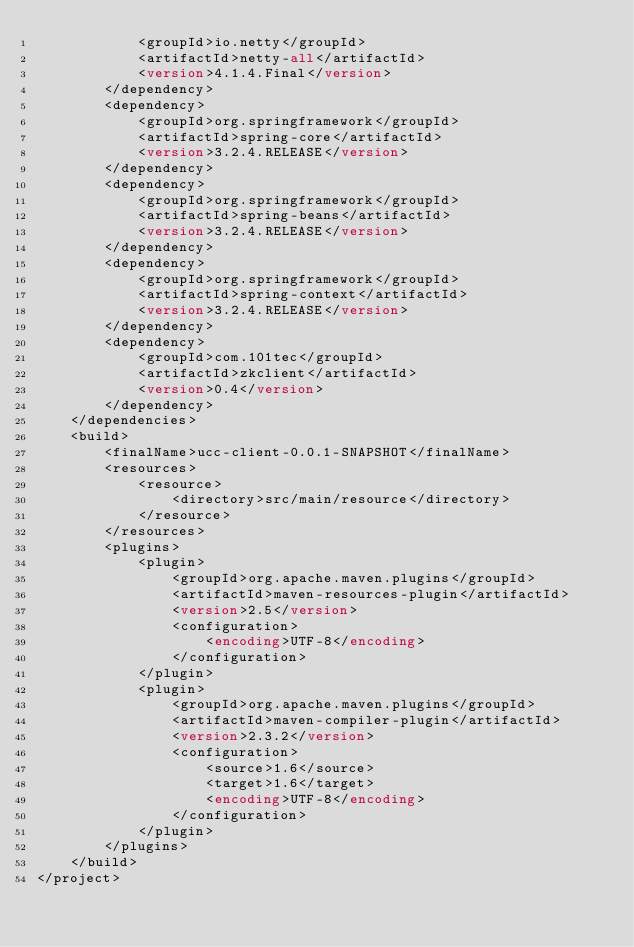<code> <loc_0><loc_0><loc_500><loc_500><_XML_>			<groupId>io.netty</groupId>
			<artifactId>netty-all</artifactId>
			<version>4.1.4.Final</version>
		</dependency>
		<dependency>
			<groupId>org.springframework</groupId>
			<artifactId>spring-core</artifactId>
			<version>3.2.4.RELEASE</version>
		</dependency>
		<dependency>
			<groupId>org.springframework</groupId>
			<artifactId>spring-beans</artifactId>
			<version>3.2.4.RELEASE</version>
		</dependency>
		<dependency>
			<groupId>org.springframework</groupId>
			<artifactId>spring-context</artifactId>
			<version>3.2.4.RELEASE</version>
		</dependency>
		<dependency>
			<groupId>com.101tec</groupId>
			<artifactId>zkclient</artifactId>
			<version>0.4</version>
		</dependency>
	</dependencies>
	<build>
		<finalName>ucc-client-0.0.1-SNAPSHOT</finalName>
		<resources>
			<resource>
				<directory>src/main/resource</directory>
			</resource>
		</resources>
		<plugins>
			<plugin>
				<groupId>org.apache.maven.plugins</groupId>
				<artifactId>maven-resources-plugin</artifactId>
				<version>2.5</version>
				<configuration>
					<encoding>UTF-8</encoding>
				</configuration>
			</plugin>
			<plugin>
				<groupId>org.apache.maven.plugins</groupId>
				<artifactId>maven-compiler-plugin</artifactId>
				<version>2.3.2</version>
				<configuration>
					<source>1.6</source>
					<target>1.6</target>
					<encoding>UTF-8</encoding>
				</configuration>
			</plugin>
		</plugins>
	</build>
</project>
</code> 